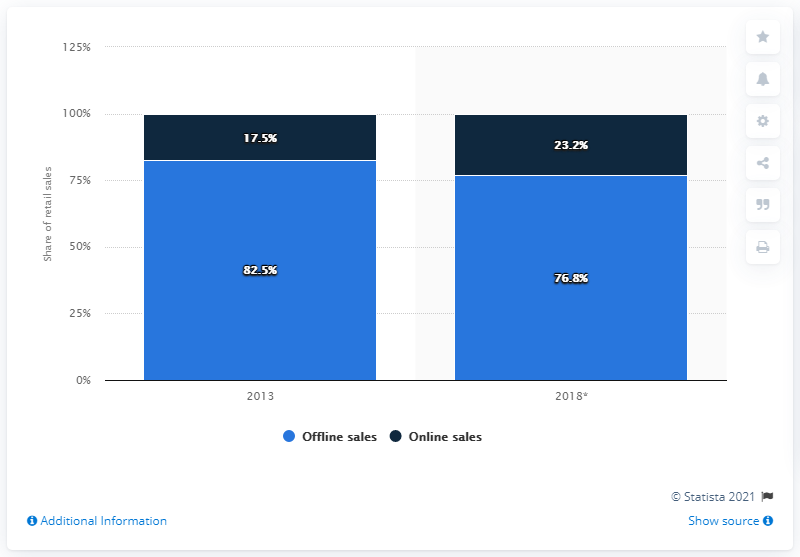Can we estimate the growth rate in the market share of online sales for electricals and electronics in Germany? Although the exact growth rate is not specified in the image, it shows an increase in the market share of online sales from 17.5% to 23.2% over a period of time. To determine the growth rate, additional data on the number of years between the two data points would be required. 